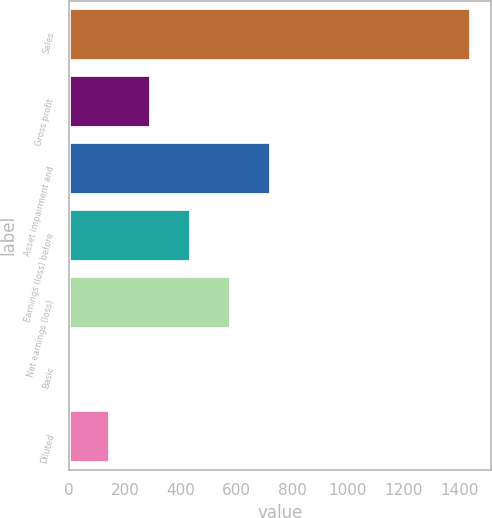Convert chart to OTSL. <chart><loc_0><loc_0><loc_500><loc_500><bar_chart><fcel>Sales<fcel>Gross profit<fcel>Asset impairment and<fcel>Earnings (loss) before<fcel>Net earnings (loss)<fcel>Basic<fcel>Diluted<nl><fcel>1444<fcel>292.27<fcel>724.18<fcel>436.24<fcel>580.21<fcel>4.35<fcel>148.31<nl></chart> 